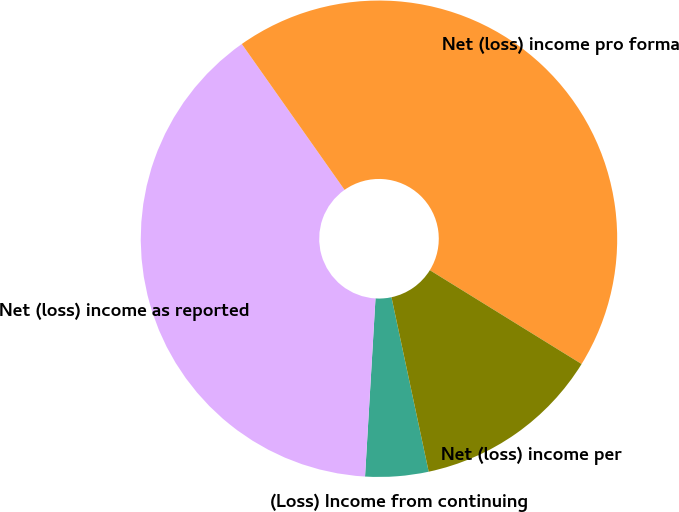Convert chart to OTSL. <chart><loc_0><loc_0><loc_500><loc_500><pie_chart><fcel>(Loss) Income from continuing<fcel>Net (loss) income as reported<fcel>Net (loss) income pro forma<fcel>Net (loss) income per<nl><fcel>4.28%<fcel>39.3%<fcel>43.58%<fcel>12.84%<nl></chart> 